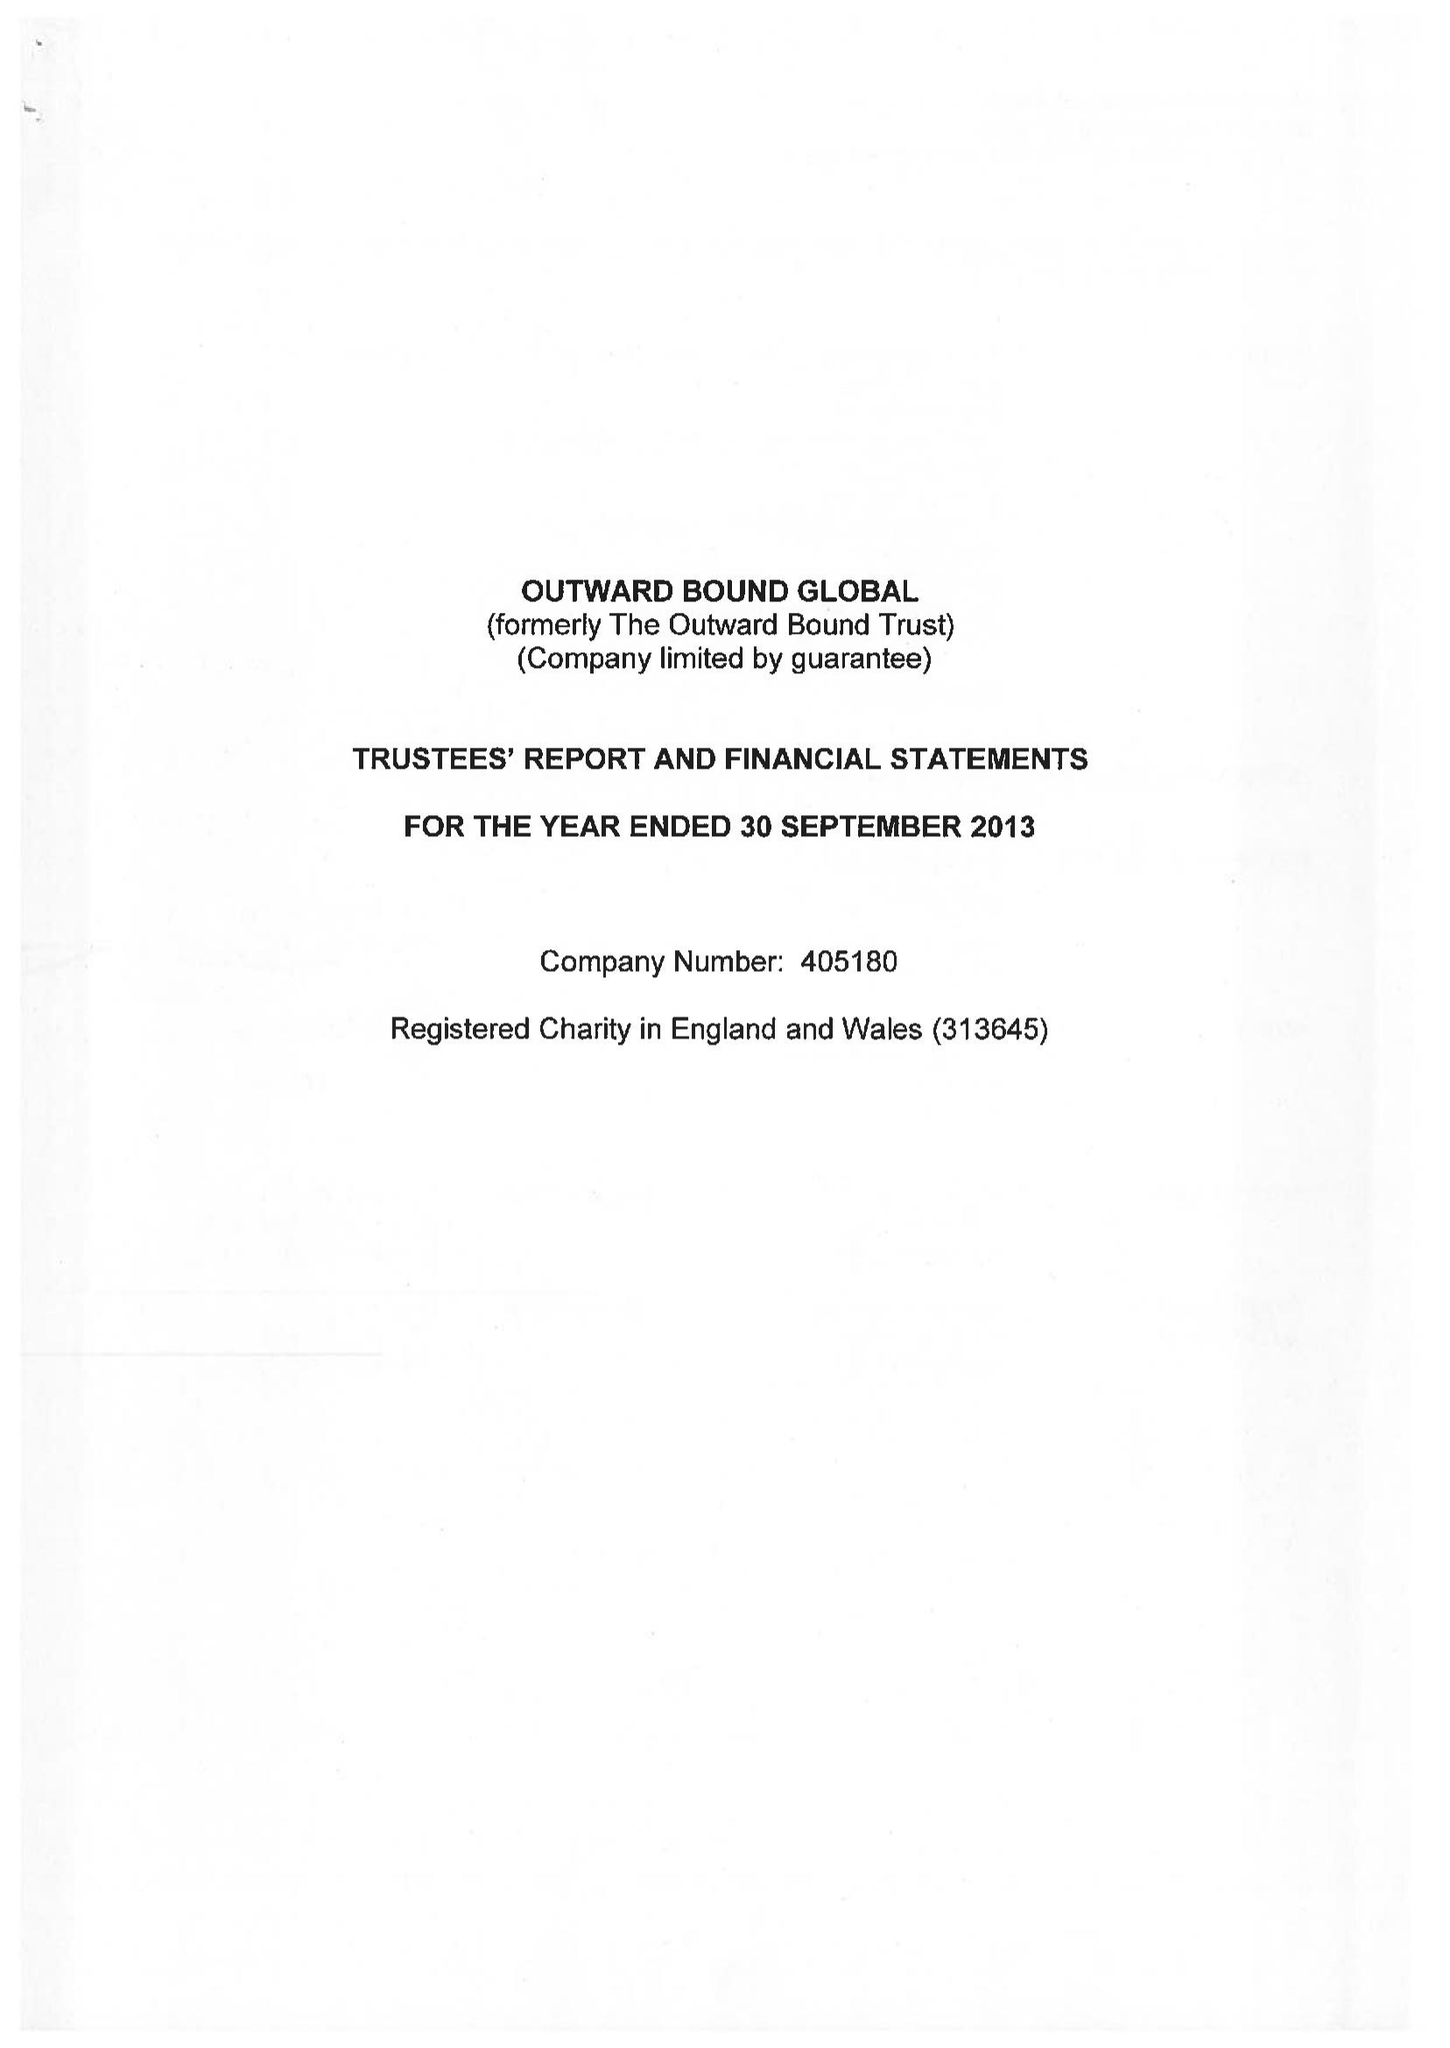What is the value for the address__post_town?
Answer the question using a single word or phrase. PENRITH 